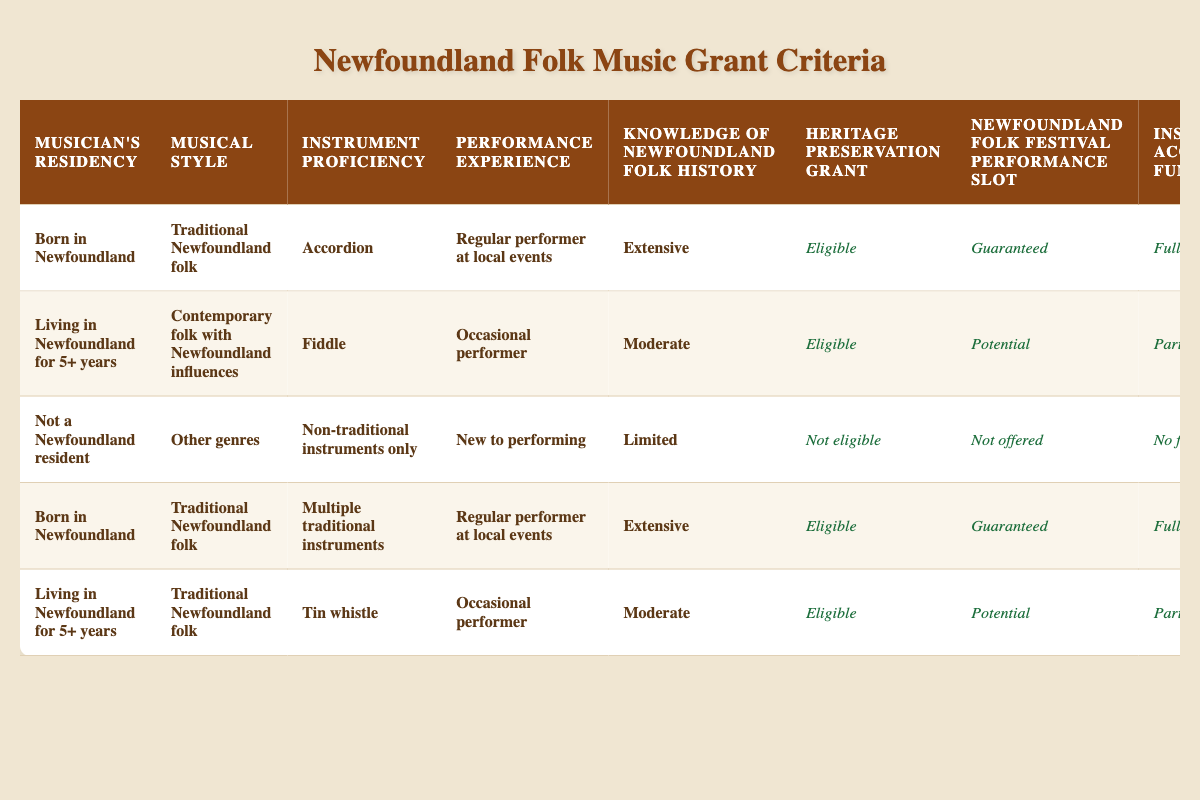What conditions qualify a musician for the Heritage Preservation Grant? According to the table, a musician is eligible for the Heritage Preservation Grant if they have residency in Newfoundland (either born in Newfoundland or living there for over 5 years), perform Traditional Newfoundland folk music, have proficiency in traditional instruments like the accordion or multiple instruments, are a regular performer at local events, and possess extensive knowledge of Newfoundland folk history.
Answer: Residency, traditional genre, proficiency in traditional instruments, regular performance, extensive knowledge Which musical styles have guaranteed performance slots at the Newfoundland Folk Festival? From the table, musicians performing Traditional Newfoundland folk music are guaranteed a slot if they are born in Newfoundland and regularly perform at local events, regardless of instrument.
Answer: Traditional Newfoundland folk music How many musicians are eligible for the Instrument Acquisition Fund with full funding? There are two conditions where musicians receive full funding: if they were born in Newfoundland, perform Traditional Newfoundland folk music, play either accordion or multiple traditional instruments, and have extensive performance experience and knowledge of folk history. Therefore, there are two qualifying conditions for full funding.
Answer: Two conditions Is a musician who plays a non-traditional instrument eligible for any funding? According to the table, musicians who play non-traditional instruments are not eligible for funding, as the rules state they are not a Newfoundland resident and engaged in other genres of music.
Answer: No What would happen if a musician occasionally performs and plays the tin whistle while living in Newfoundland for more than five years? Musicians living in Newfoundland for more than five years, playing the tin whistle, and having occasional performance experience are eligible for partial funding and an invitation as a participant. This confirms they have access to some level of support.
Answer: Eligible for partial funding Are musicians with limited knowledge of Newfoundland folk history eligible to be invited to workshops? Based on the table's rules, musicians with limited knowledge of folk history are not invited to workshops, as seen in the conditions for non-eligible musicians and their lack of invitations.
Answer: No Which instrument proficiency is linked to invitations as instructors at traditional music workshops? The table indicates that musicians proficient in the accordion or multiple traditional instruments and who regularly perform at local events are invited as instructors at traditional music workshops.
Answer: Accordion or multiple traditional instruments What residency and performance experience conditions qualify a musician for the Newfoundland Folk Festival? A musician can secure a guaranteed performance slot at the Newfoundland Folk Festival if they are born in Newfoundland, perform traditional Newfoundland folk music, play the accordion or multiple traditional instruments, and have regular performance experience.
Answer: Born in Newfoundland, regular performer 